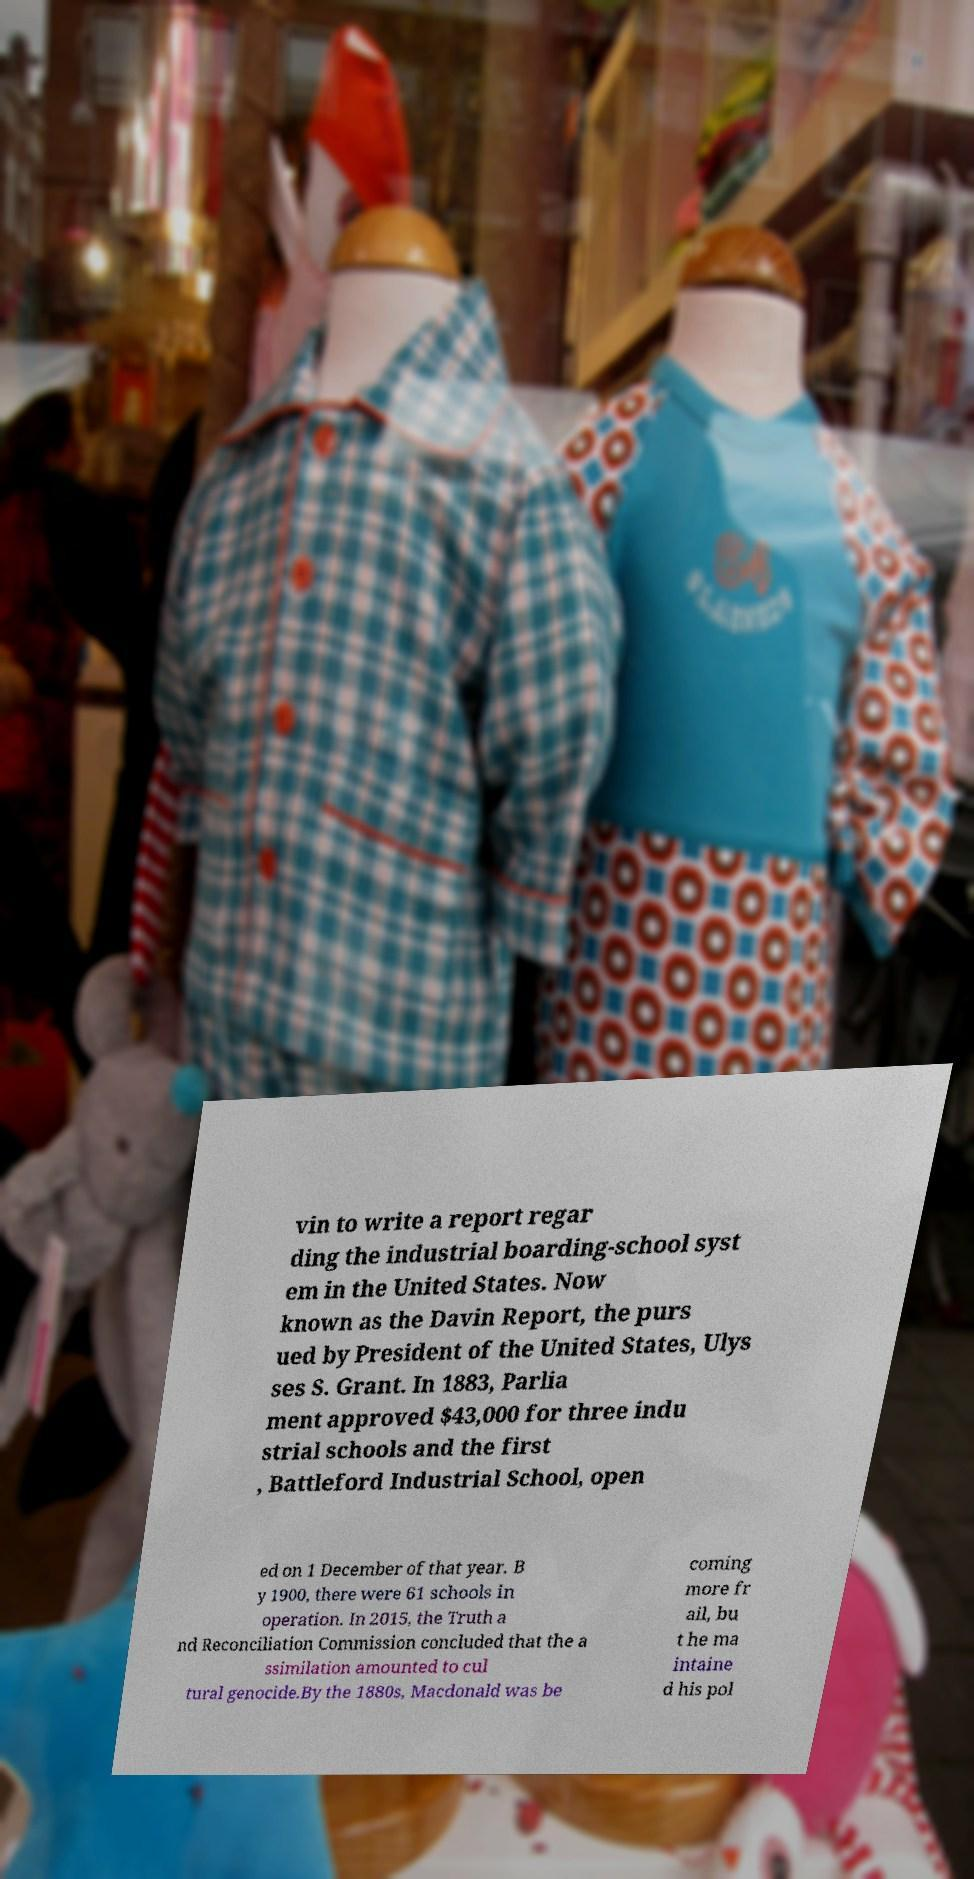I need the written content from this picture converted into text. Can you do that? vin to write a report regar ding the industrial boarding-school syst em in the United States. Now known as the Davin Report, the purs ued by President of the United States, Ulys ses S. Grant. In 1883, Parlia ment approved $43,000 for three indu strial schools and the first , Battleford Industrial School, open ed on 1 December of that year. B y 1900, there were 61 schools in operation. In 2015, the Truth a nd Reconciliation Commission concluded that the a ssimilation amounted to cul tural genocide.By the 1880s, Macdonald was be coming more fr ail, bu t he ma intaine d his pol 